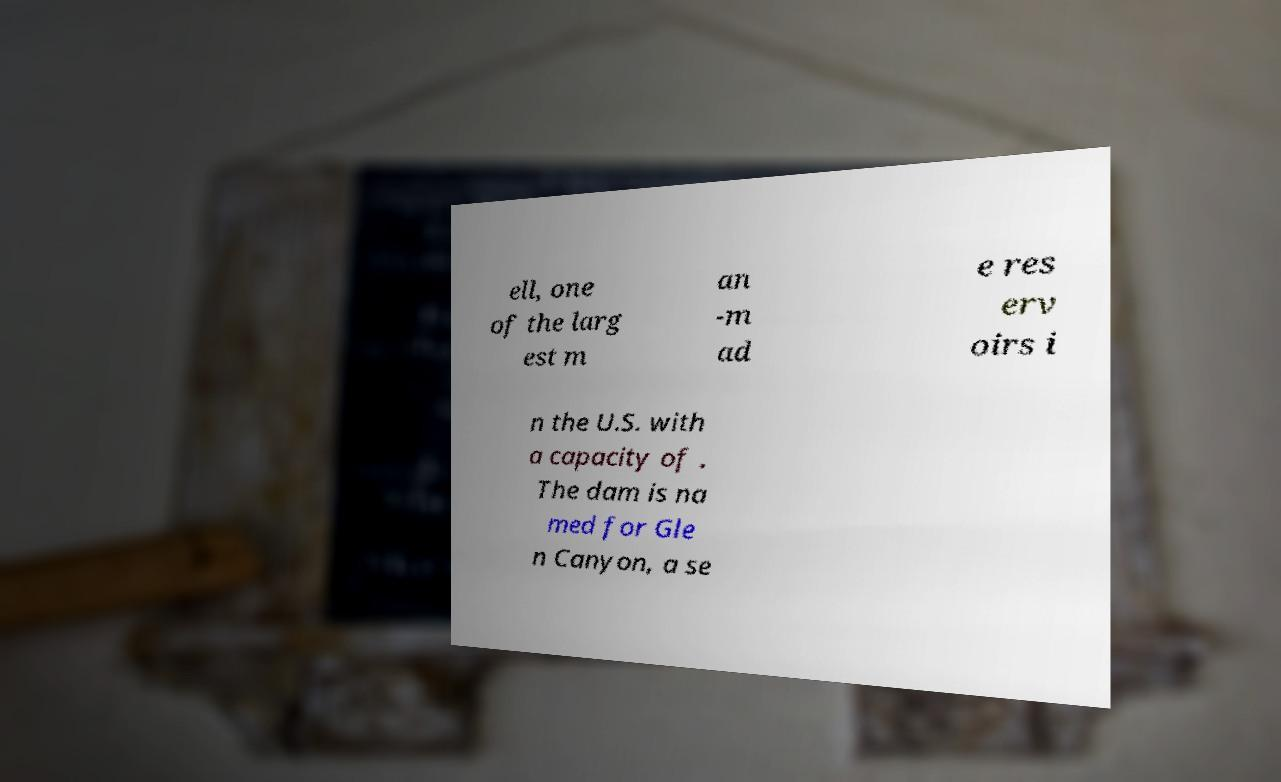Please identify and transcribe the text found in this image. ell, one of the larg est m an -m ad e res erv oirs i n the U.S. with a capacity of . The dam is na med for Gle n Canyon, a se 